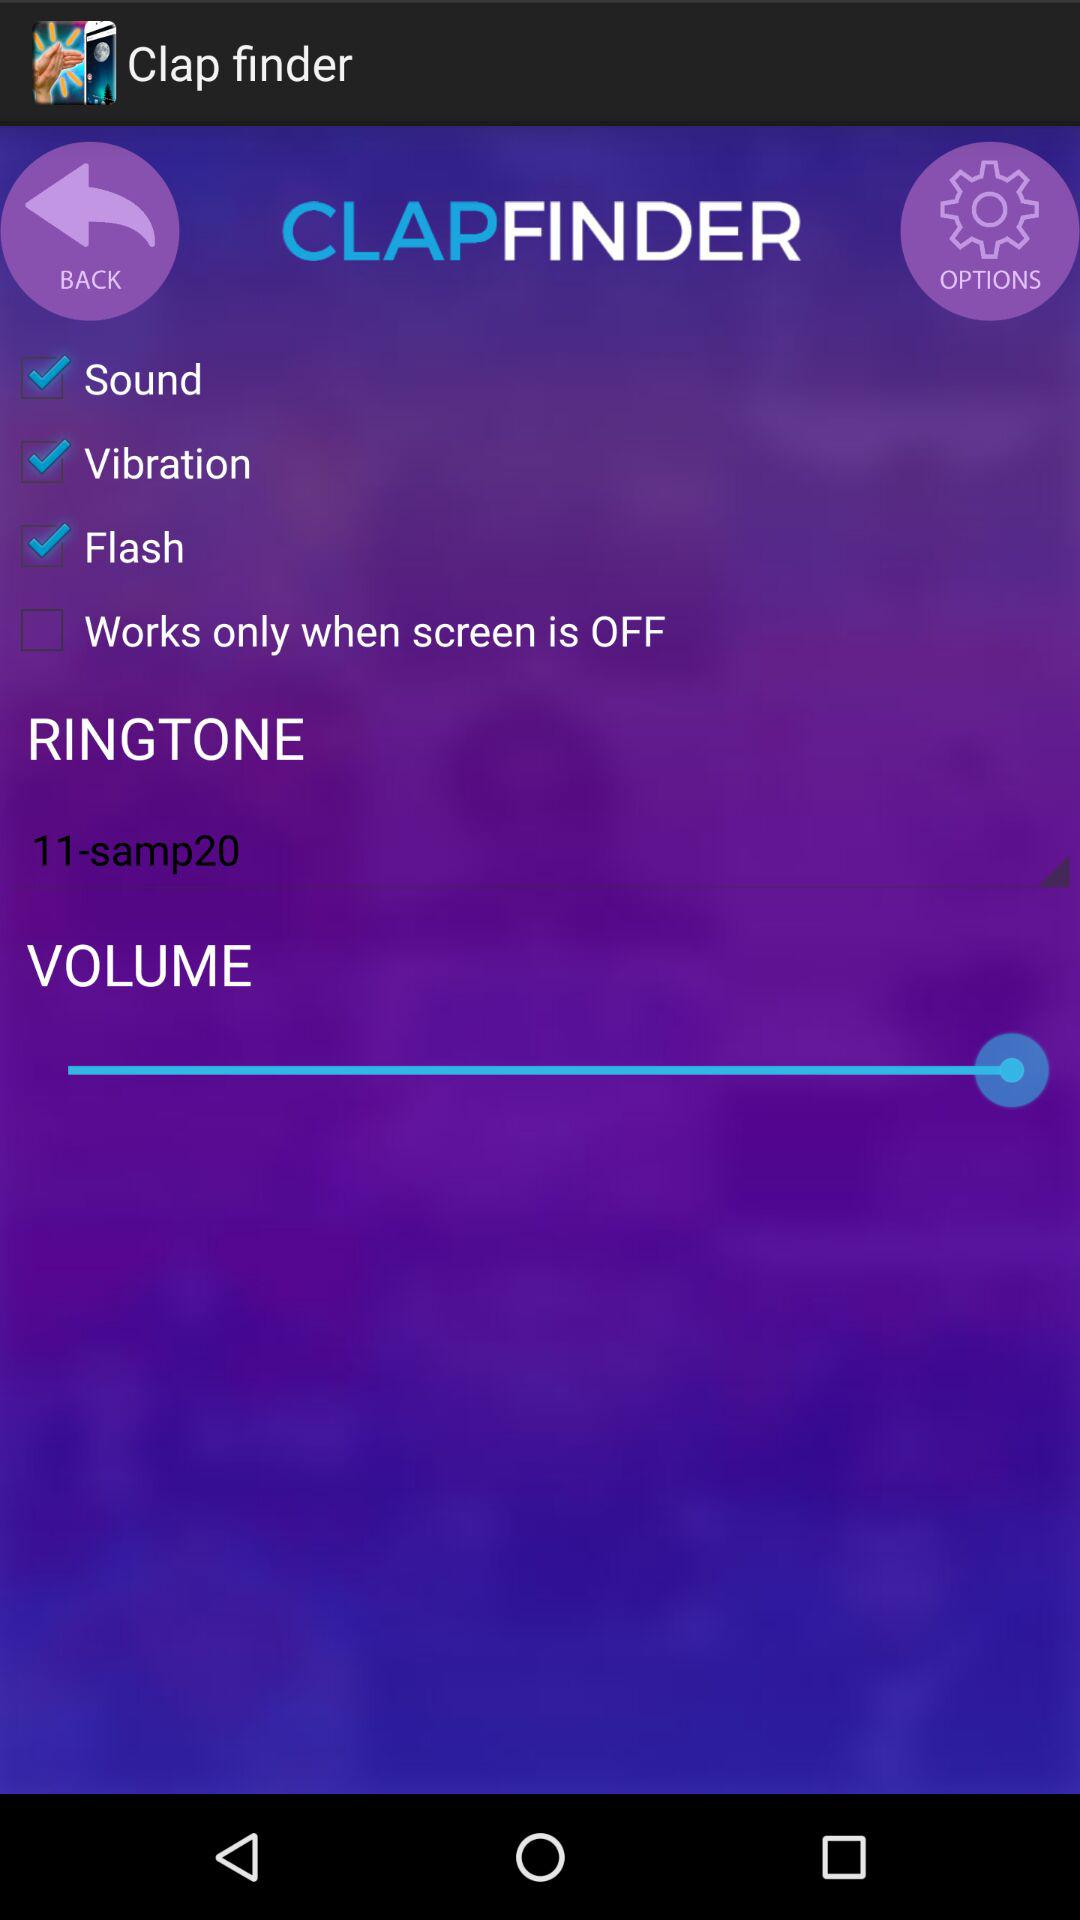What is the status of "Flash"? The status is "on". 